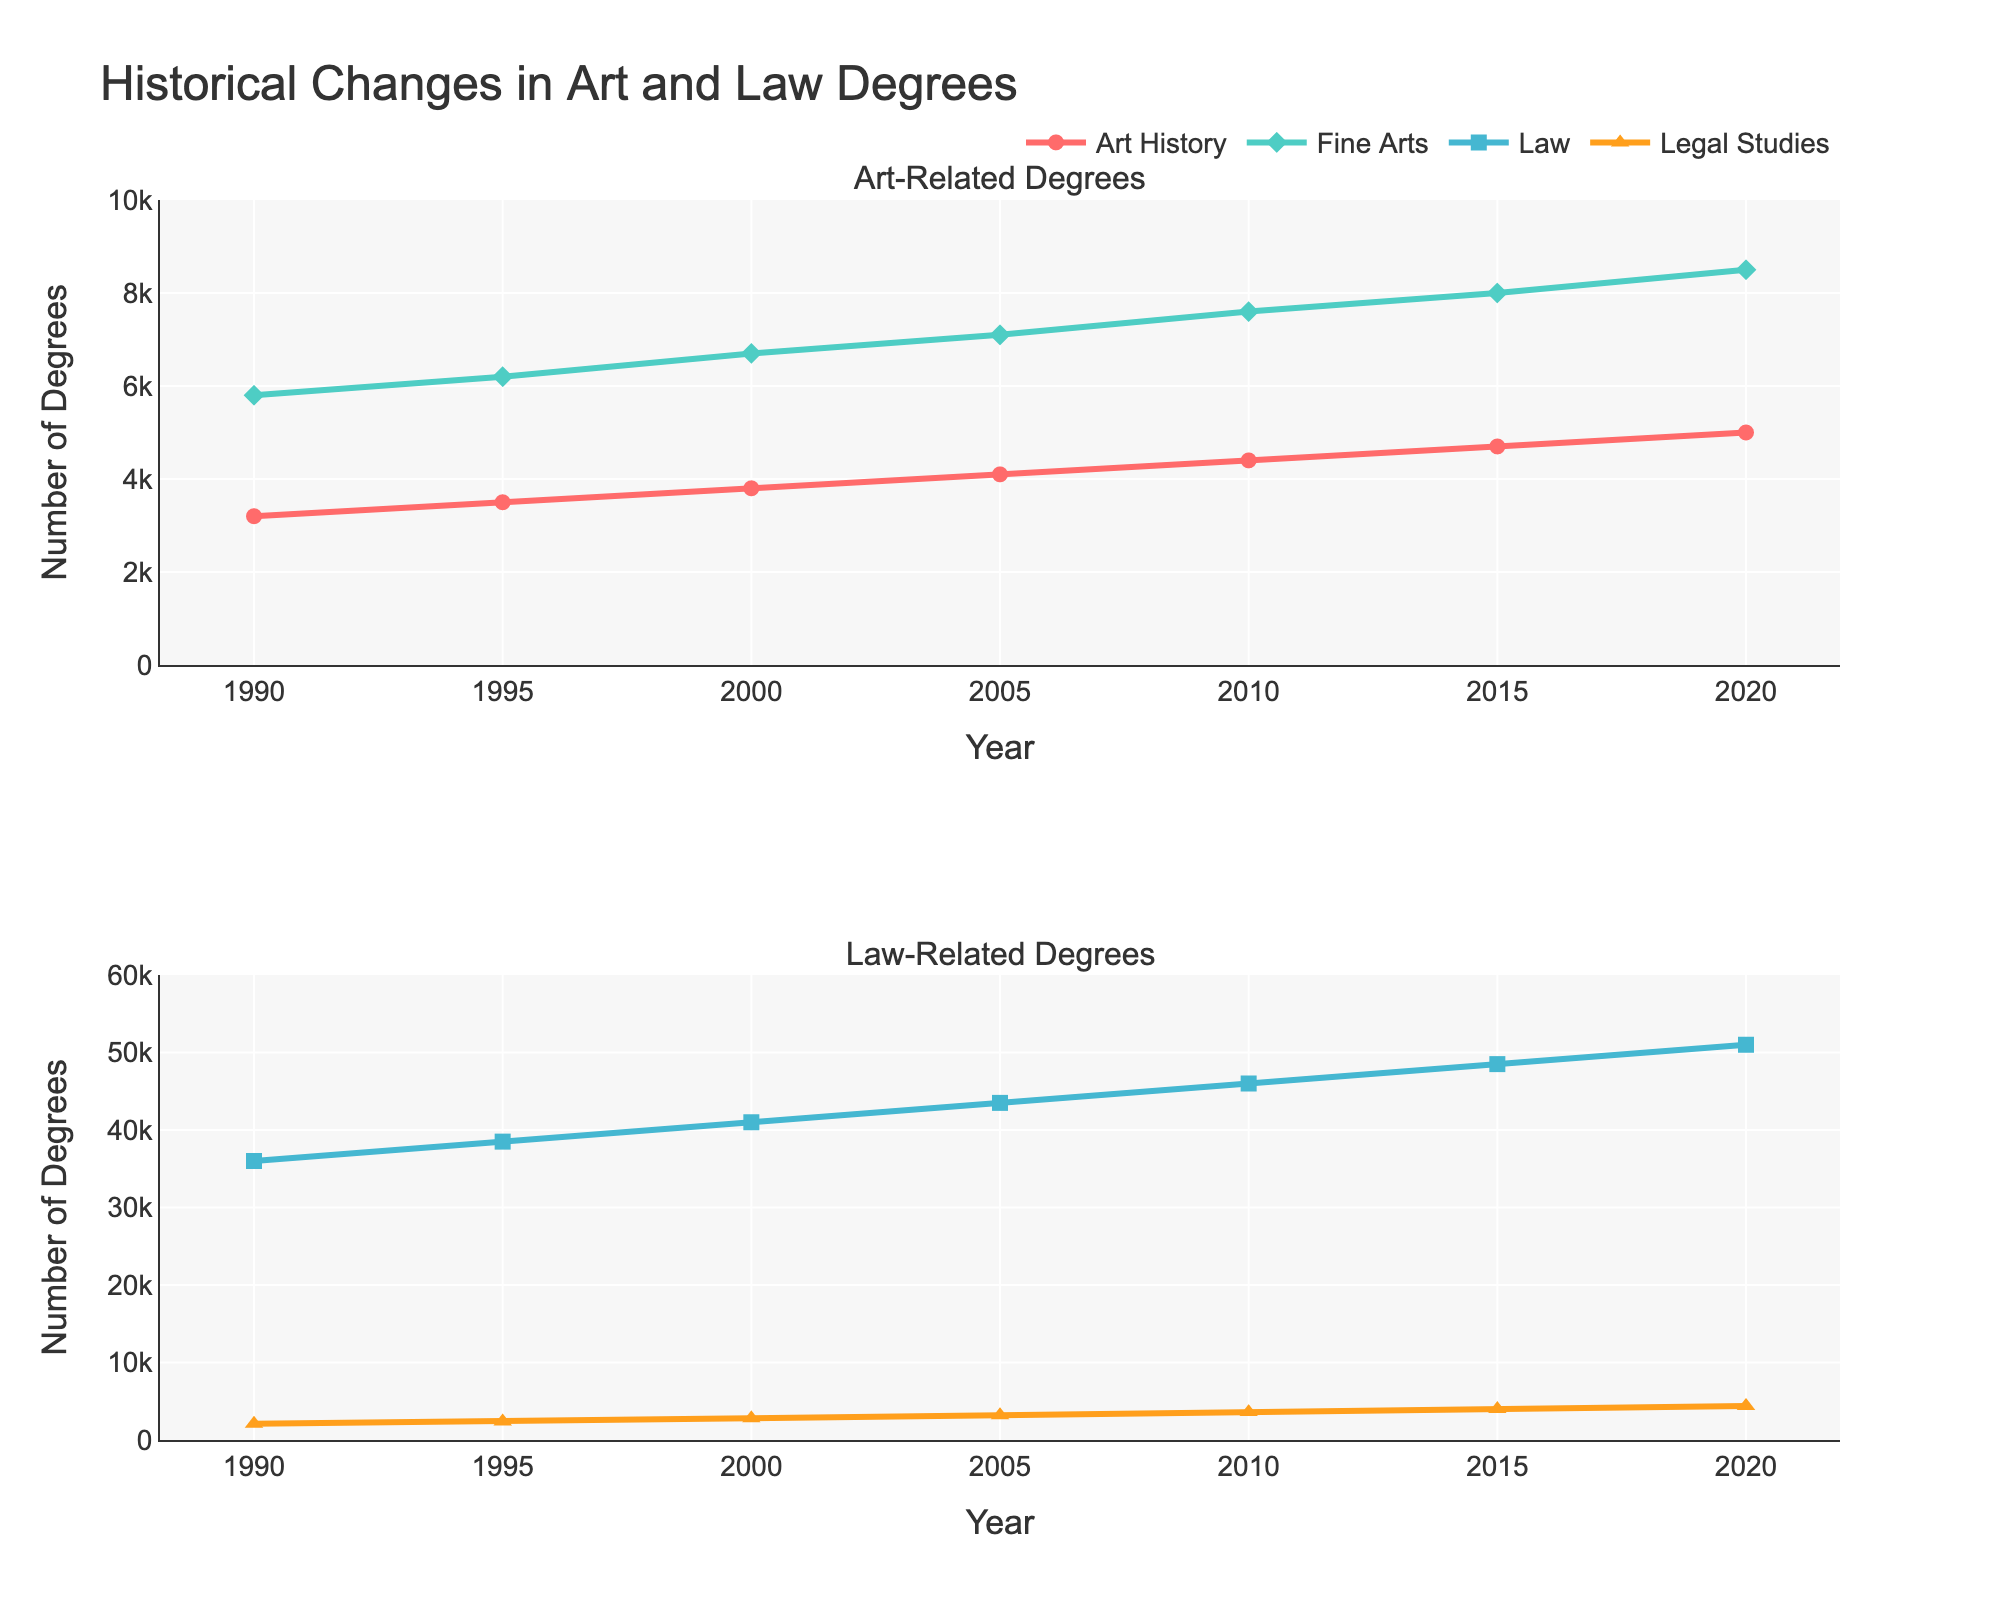What is the title of the figure? The title of the figure is located at the top and usually summarizes the overall content of the plot.
Answer: Historical Changes in Art and Law Degrees How many subplots are there in the figure? By examining the layout of the figure, it's clear there are two distinct sections or subplots.
Answer: Two Which degree has the highest number of awards in 2020? In 2020, the highest number of degrees awarded can be identified by looking at the endpoints of the lines in the figure.
Answer: Law Degrees What is the color of the line representing Fine Arts Degrees? By looking at the figure, you can identify the color corresponding to the Fine Arts Degrees line.
Answer: Teal Between 1990 and 2020, by how much did the number of Art History Degrees increase? Subtract the number of degrees in 1990 from the number in 2020 for Art History Degrees.
Answer: 1800 Which degrees have more variability in numbers over the observed years, Art-related or Law-related? Observe the range of the two subplots. Art-related degrees range from 3200 to 8500, whereas Law-related degrees range from 2100 to 51000.
Answer: Law-related degrees Between 2000 and 2015, which degree saw the highest absolute increase in number? Calculate the differences for each degree between 2000 and 2015, and identify the largest increase.
Answer: Law Degrees What is the symbol used to represent Legal Studies Degrees? Each line plot uses different marker symbols, and the one for Legal Studies Degrees should be identified.
Answer: Triangle-up Did any Art-related degrees exceed 8000 annually before 2015? Look at the values on the y-axis of the first subplot to see if any data points exceed 8000 before 2015.
Answer: No Which Art-related degree had more awards in 2005, Art History Degrees or Fine Arts Degrees? Compare the values for both degrees in 2005 on the first subplot.
Answer: Fine Arts Degrees 